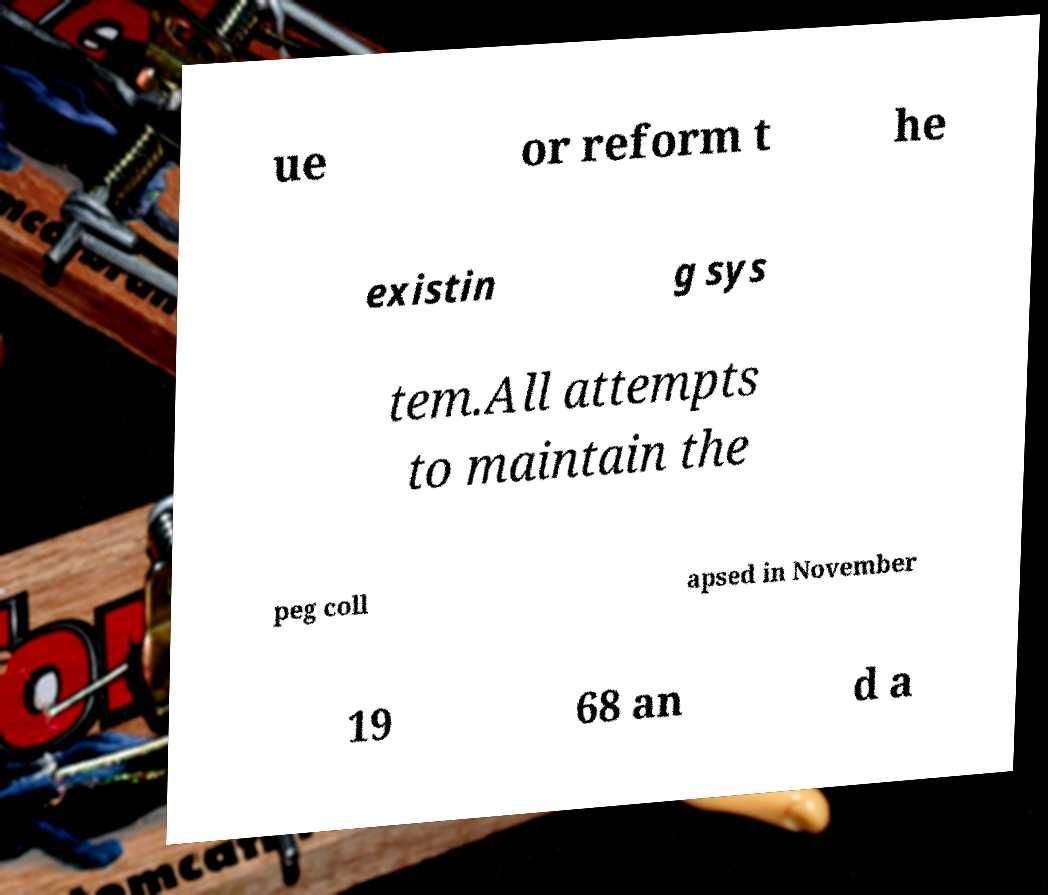I need the written content from this picture converted into text. Can you do that? ue or reform t he existin g sys tem.All attempts to maintain the peg coll apsed in November 19 68 an d a 